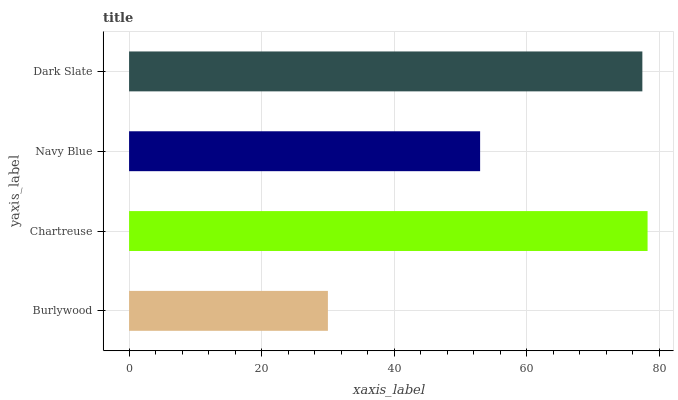Is Burlywood the minimum?
Answer yes or no. Yes. Is Chartreuse the maximum?
Answer yes or no. Yes. Is Navy Blue the minimum?
Answer yes or no. No. Is Navy Blue the maximum?
Answer yes or no. No. Is Chartreuse greater than Navy Blue?
Answer yes or no. Yes. Is Navy Blue less than Chartreuse?
Answer yes or no. Yes. Is Navy Blue greater than Chartreuse?
Answer yes or no. No. Is Chartreuse less than Navy Blue?
Answer yes or no. No. Is Dark Slate the high median?
Answer yes or no. Yes. Is Navy Blue the low median?
Answer yes or no. Yes. Is Navy Blue the high median?
Answer yes or no. No. Is Chartreuse the low median?
Answer yes or no. No. 